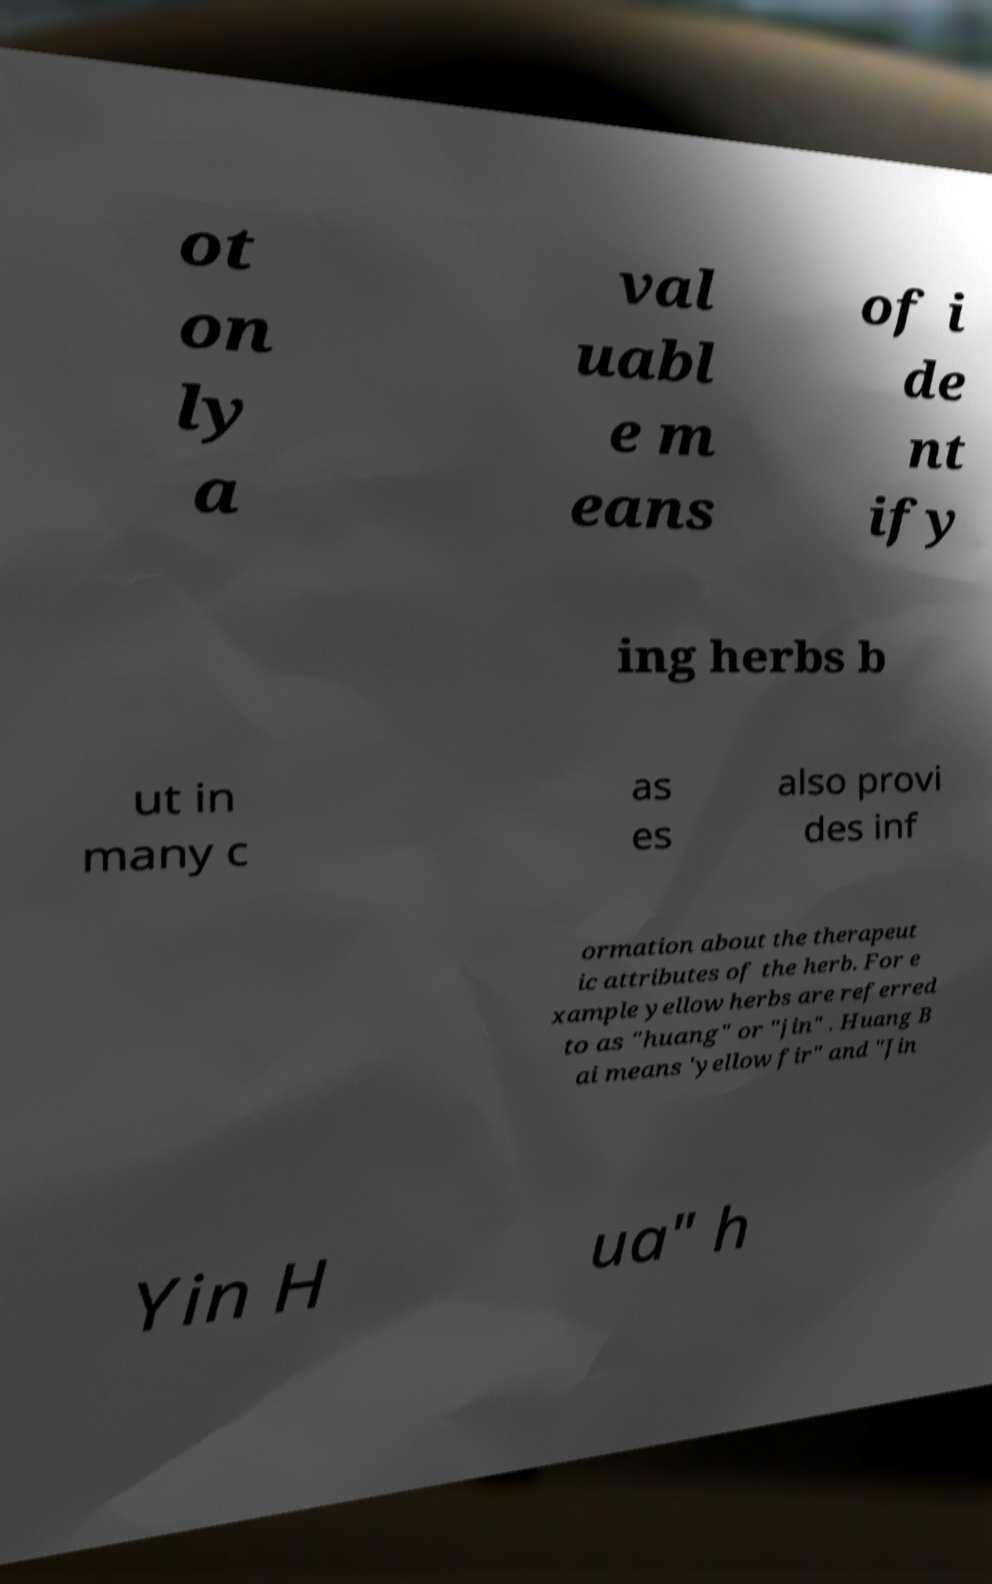Please read and relay the text visible in this image. What does it say? ot on ly a val uabl e m eans of i de nt ify ing herbs b ut in many c as es also provi des inf ormation about the therapeut ic attributes of the herb. For e xample yellow herbs are referred to as "huang" or "jin" . Huang B ai means 'yellow fir" and "Jin Yin H ua" h 